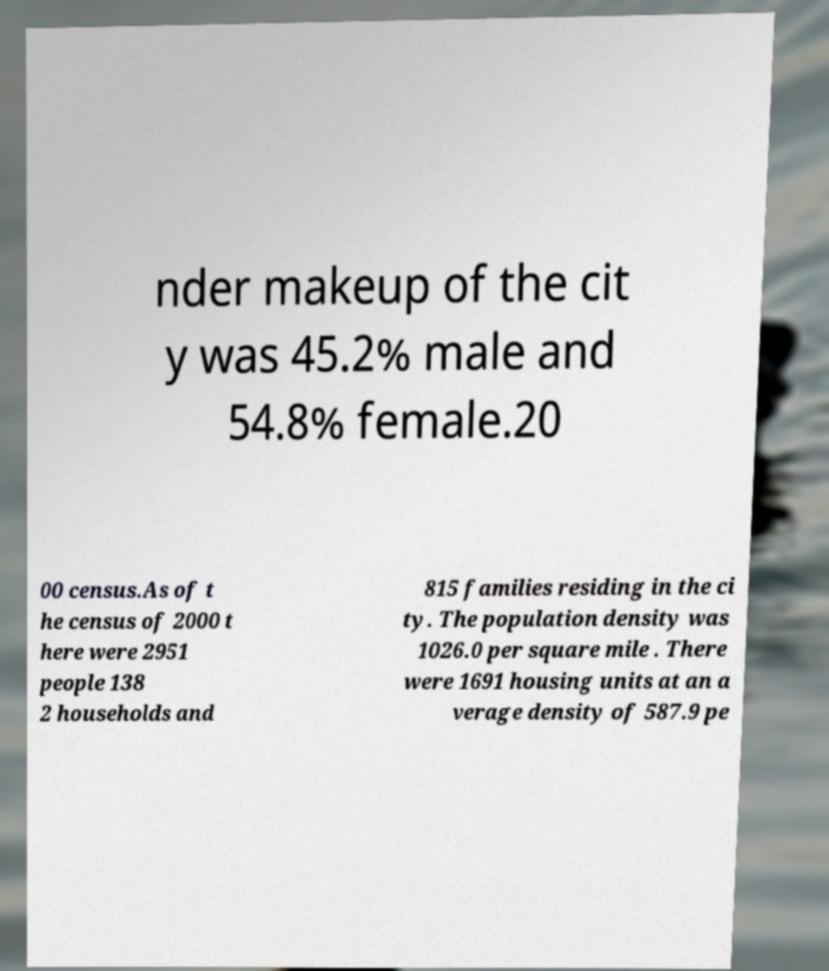What messages or text are displayed in this image? I need them in a readable, typed format. nder makeup of the cit y was 45.2% male and 54.8% female.20 00 census.As of t he census of 2000 t here were 2951 people 138 2 households and 815 families residing in the ci ty. The population density was 1026.0 per square mile . There were 1691 housing units at an a verage density of 587.9 pe 